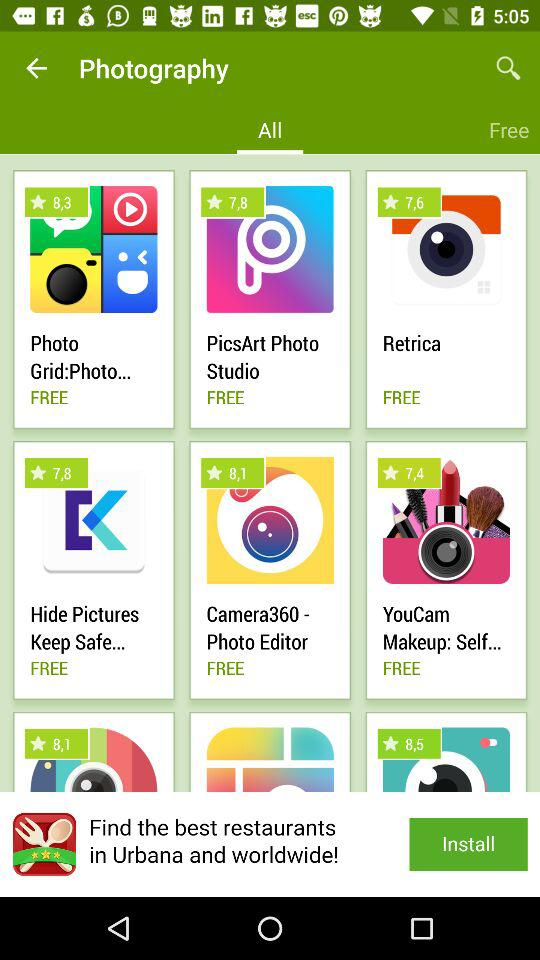What is the rating for the "Camera360 - Photo Editor" app? The rating is 8.1. 